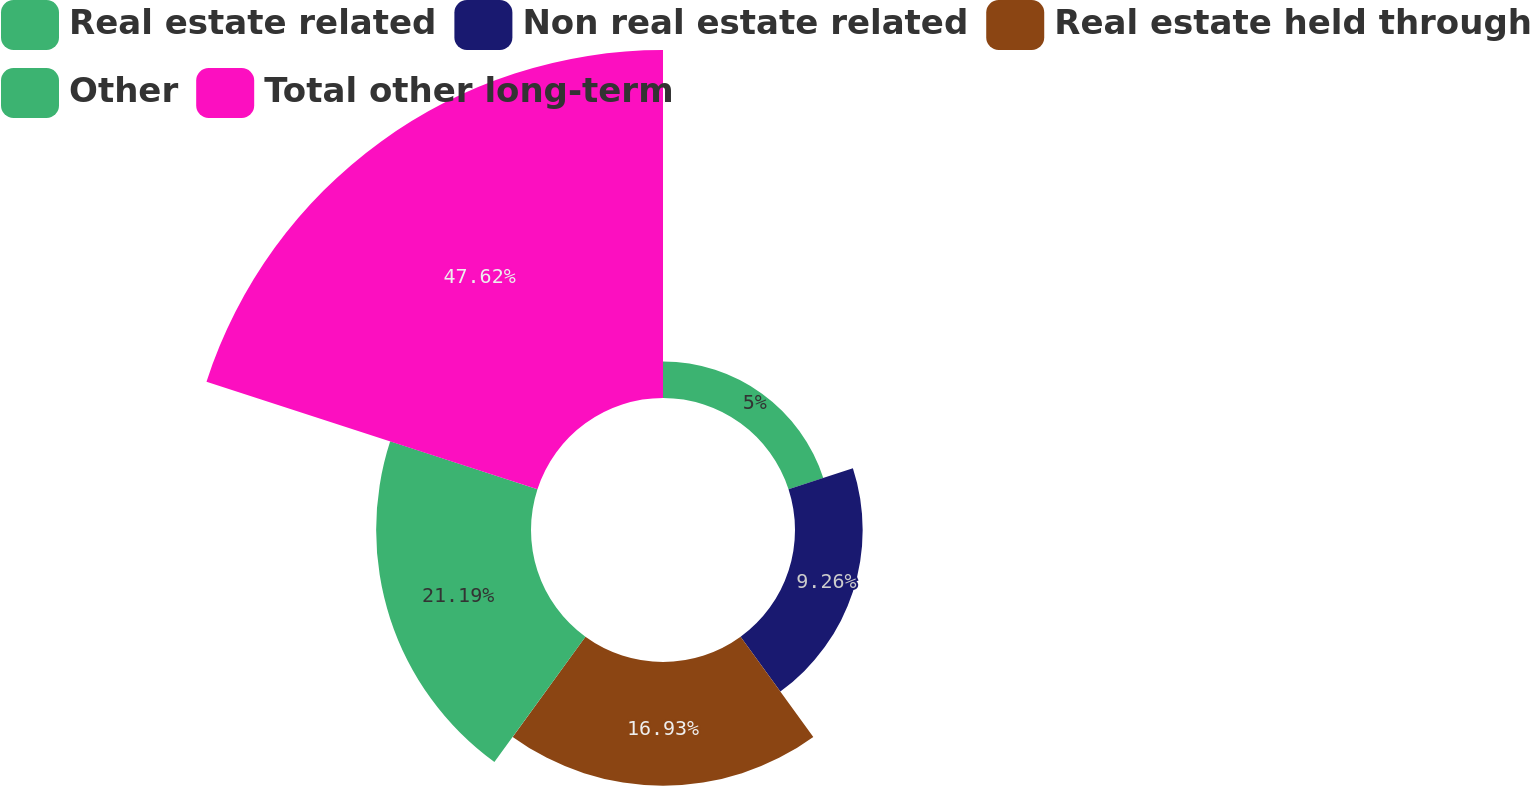Convert chart to OTSL. <chart><loc_0><loc_0><loc_500><loc_500><pie_chart><fcel>Real estate related<fcel>Non real estate related<fcel>Real estate held through<fcel>Other<fcel>Total other long-term<nl><fcel>5.0%<fcel>9.26%<fcel>16.93%<fcel>21.19%<fcel>47.62%<nl></chart> 